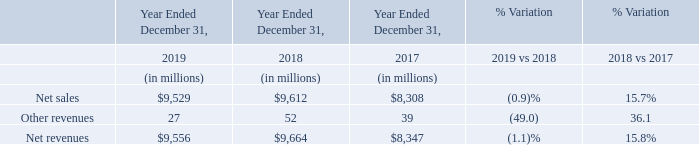Our 2019 net revenues decreased 1.1% compared to the prior year, primarily due to a decrease in volumes of approximately 8%, partially compensated by an increase in average selling prices of approximately 7%. The increase in the average selling prices was driven by favorable product mix of approximately 10%, partially offset by a negative pricing effect of approximately 3%.
Our 2018 net revenues increased 15.8% compared to the prior year, primarily due to increase in average selling prices of approximately 16%, while volumes remained substantially flat. The increase in the average selling prices was driven by favorable product mix of approximately 18%, partially offset by a negative pricing effect of approximately 2%. Our net revenues registered double-digit growth across all product groups and geographies.
In 2019, 2018 and 2017, our largest customer, Apple, accounted for 17.6%, 13.1% and 10.5% of our net revenues, respectively, reported within our three product groups.
Why did the 2019 net revenues decreased 1.1% compared to the prior year? A decrease in volumes of approximately 8%, partially compensated by an increase in average selling prices of approximately 7%. Why did the 2018 net revenues increased 15.8% compared to the prior year? Increase in average selling prices of approximately 16%, while volumes remained substantially flat. What was the share of Apple in the net revenues in 2019, 2018 and 2017? 17.6%, 13.1% and 10.5%. What are the average Net sales?
Answer scale should be: million. (9,529+9,612+8,308) / 3
Answer: 9149.67. What are the average other revenues?
Answer scale should be: million. (27+52+39) / 3
Answer: 39.33. What are the average Net revenues?
Answer scale should be: million. (9,556+9,664+8,347 ) / 3
Answer: 9189. 